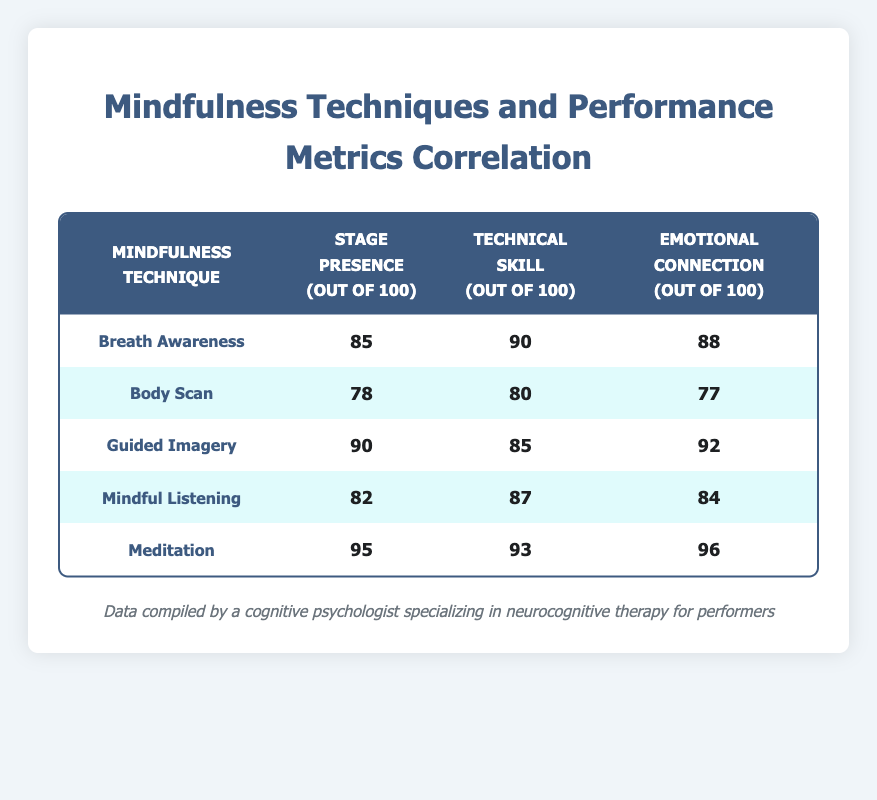What is the performance metric score for Meditation in terms of Stage Presence? From the table, locate the row for the mindfulness technique "Meditation". The Stage Presence value for Meditation is listed as 95.
Answer: 95 Which mindfulness technique has the highest score in Emotional Connection? By examining the Emotional Connection column, the scores are as follows: Breath Awareness (88), Body Scan (77), Guided Imagery (92), Mindful Listening (84), and Meditation (96). The highest score is 96, belonging to Meditation.
Answer: Meditation What is the average score for Technical Skill across all mindfulness techniques? To find the average score for Technical Skill, sum the scores: 90 + 80 + 85 + 87 + 93 = 435. Then divide by the number of techniques (5): 435 / 5 = 87.
Answer: 87 Is the score for Breath Awareness in Stage Presence greater than that for Body Scan in Technical Skill? Compare the Stage Presence score for Breath Awareness (85) with the Technical Skill score for Body Scan (80). Since 85 is greater than 80, the statement is true.
Answer: Yes What is the difference in performance metric scores between Guided Imagery and Mindful Listening for Emotional Connection? The Emotional Connection scores for Guided Imagery and Mindful Listening are 92 and 84, respectively. The difference is calculated as 92 - 84 = 8.
Answer: 8 Which technique shows the lowest score in Stage Presence, and what is that score? Check the Stage Presence scores: Breath Awareness (85), Body Scan (78), Guided Imagery (90), Mindful Listening (82), and Meditation (95). The lowest score is 78 for Body Scan.
Answer: Body Scan, 78 If you consider all scores for Technical Skill, how many scores are above 85? The scores for Technical Skill are: 90, 80, 85, 87, and 93. The scores above 85 are 90, 87, and 93, totaling three scores.
Answer: 3 Which mindfulness technique has the highest combined score across all three performance metrics? Calculate the total score for each technique: Breath Awareness (85 + 90 + 88 = 263), Body Scan (78 + 80 + 77 = 235), Guided Imagery (90 + 85 + 92 = 267), Mindful Listening (82 + 87 + 84 = 253), Meditation (95 + 93 + 96 = 284). Meditation has the highest total of 284.
Answer: Meditation, 284 What is the median score for Emotional Connection across all techniques? List the Emotional Connection scores in order: 77, 84, 88, 92, 96. The median is the middle score in this ordered list, which is 88.
Answer: 88 